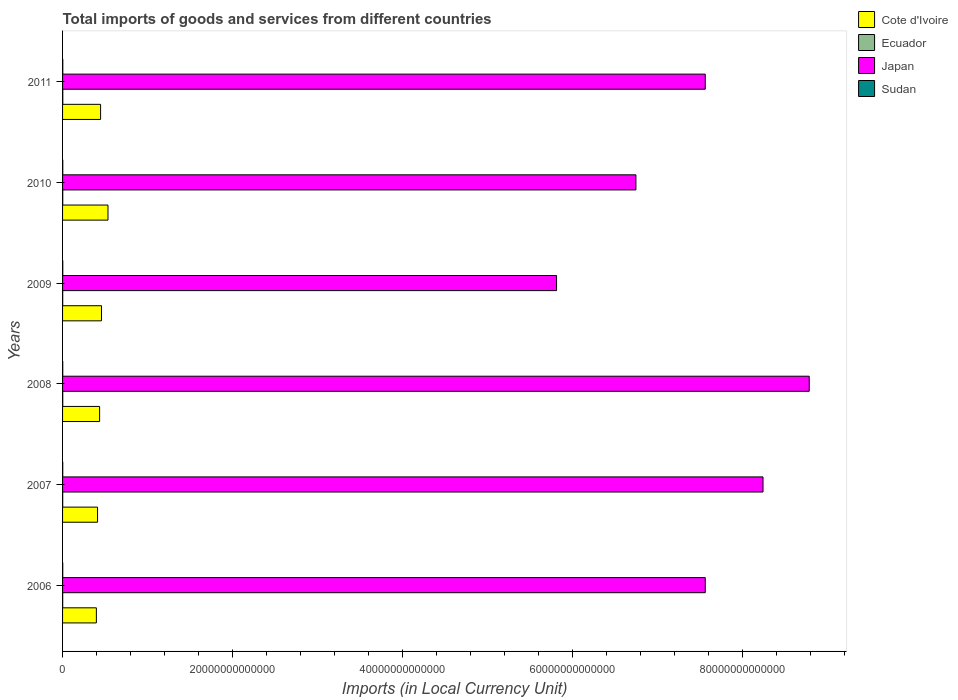How many different coloured bars are there?
Your answer should be compact. 4. How many groups of bars are there?
Your response must be concise. 6. Are the number of bars per tick equal to the number of legend labels?
Make the answer very short. Yes. Are the number of bars on each tick of the Y-axis equal?
Give a very brief answer. Yes. How many bars are there on the 1st tick from the bottom?
Provide a short and direct response. 4. What is the label of the 5th group of bars from the top?
Keep it short and to the point. 2007. In how many cases, is the number of bars for a given year not equal to the number of legend labels?
Keep it short and to the point. 0. What is the Amount of goods and services imports in Sudan in 2008?
Ensure brevity in your answer.  2.23e+1. Across all years, what is the maximum Amount of goods and services imports in Sudan?
Your response must be concise. 2.79e+1. Across all years, what is the minimum Amount of goods and services imports in Ecuador?
Your response must be concise. 1.37e+1. What is the total Amount of goods and services imports in Japan in the graph?
Offer a very short reply. 4.47e+14. What is the difference between the Amount of goods and services imports in Ecuador in 2008 and that in 2011?
Offer a very short reply. -5.52e+09. What is the difference between the Amount of goods and services imports in Ecuador in 2009 and the Amount of goods and services imports in Sudan in 2007?
Offer a terse response. -4.18e+09. What is the average Amount of goods and services imports in Ecuador per year?
Provide a succinct answer. 1.94e+1. In the year 2006, what is the difference between the Amount of goods and services imports in Ecuador and Amount of goods and services imports in Cote d'Ivoire?
Offer a terse response. -3.96e+12. What is the ratio of the Amount of goods and services imports in Sudan in 2007 to that in 2008?
Offer a very short reply. 0.94. Is the Amount of goods and services imports in Sudan in 2007 less than that in 2008?
Ensure brevity in your answer.  Yes. What is the difference between the highest and the second highest Amount of goods and services imports in Japan?
Provide a short and direct response. 5.43e+12. What is the difference between the highest and the lowest Amount of goods and services imports in Japan?
Make the answer very short. 2.97e+13. Is the sum of the Amount of goods and services imports in Sudan in 2006 and 2007 greater than the maximum Amount of goods and services imports in Japan across all years?
Keep it short and to the point. No. Is it the case that in every year, the sum of the Amount of goods and services imports in Sudan and Amount of goods and services imports in Japan is greater than the sum of Amount of goods and services imports in Cote d'Ivoire and Amount of goods and services imports in Ecuador?
Provide a short and direct response. Yes. What does the 2nd bar from the bottom in 2009 represents?
Give a very brief answer. Ecuador. Are all the bars in the graph horizontal?
Give a very brief answer. Yes. What is the difference between two consecutive major ticks on the X-axis?
Your response must be concise. 2.00e+13. Are the values on the major ticks of X-axis written in scientific E-notation?
Offer a terse response. No. Does the graph contain grids?
Ensure brevity in your answer.  No. Where does the legend appear in the graph?
Give a very brief answer. Top right. What is the title of the graph?
Your response must be concise. Total imports of goods and services from different countries. Does "Turkey" appear as one of the legend labels in the graph?
Give a very brief answer. No. What is the label or title of the X-axis?
Ensure brevity in your answer.  Imports (in Local Currency Unit). What is the label or title of the Y-axis?
Offer a terse response. Years. What is the Imports (in Local Currency Unit) of Cote d'Ivoire in 2006?
Offer a terse response. 3.97e+12. What is the Imports (in Local Currency Unit) of Ecuador in 2006?
Make the answer very short. 1.37e+1. What is the Imports (in Local Currency Unit) in Japan in 2006?
Your answer should be very brief. 7.56e+13. What is the Imports (in Local Currency Unit) of Sudan in 2006?
Ensure brevity in your answer.  2.07e+1. What is the Imports (in Local Currency Unit) of Cote d'Ivoire in 2007?
Offer a terse response. 4.12e+12. What is the Imports (in Local Currency Unit) of Ecuador in 2007?
Your response must be concise. 1.56e+1. What is the Imports (in Local Currency Unit) in Japan in 2007?
Ensure brevity in your answer.  8.24e+13. What is the Imports (in Local Currency Unit) in Sudan in 2007?
Your answer should be compact. 2.10e+1. What is the Imports (in Local Currency Unit) of Cote d'Ivoire in 2008?
Your answer should be very brief. 4.36e+12. What is the Imports (in Local Currency Unit) of Ecuador in 2008?
Keep it short and to the point. 2.09e+1. What is the Imports (in Local Currency Unit) of Japan in 2008?
Provide a succinct answer. 8.78e+13. What is the Imports (in Local Currency Unit) in Sudan in 2008?
Keep it short and to the point. 2.23e+1. What is the Imports (in Local Currency Unit) in Cote d'Ivoire in 2009?
Your answer should be compact. 4.58e+12. What is the Imports (in Local Currency Unit) in Ecuador in 2009?
Ensure brevity in your answer.  1.68e+1. What is the Imports (in Local Currency Unit) in Japan in 2009?
Make the answer very short. 5.81e+13. What is the Imports (in Local Currency Unit) in Sudan in 2009?
Offer a very short reply. 2.45e+1. What is the Imports (in Local Currency Unit) in Cote d'Ivoire in 2010?
Provide a succinct answer. 5.34e+12. What is the Imports (in Local Currency Unit) of Ecuador in 2010?
Your answer should be compact. 2.25e+1. What is the Imports (in Local Currency Unit) in Japan in 2010?
Your answer should be very brief. 6.74e+13. What is the Imports (in Local Currency Unit) in Sudan in 2010?
Offer a very short reply. 2.61e+1. What is the Imports (in Local Currency Unit) of Cote d'Ivoire in 2011?
Provide a short and direct response. 4.47e+12. What is the Imports (in Local Currency Unit) of Ecuador in 2011?
Your response must be concise. 2.65e+1. What is the Imports (in Local Currency Unit) in Japan in 2011?
Your response must be concise. 7.56e+13. What is the Imports (in Local Currency Unit) of Sudan in 2011?
Keep it short and to the point. 2.79e+1. Across all years, what is the maximum Imports (in Local Currency Unit) in Cote d'Ivoire?
Your response must be concise. 5.34e+12. Across all years, what is the maximum Imports (in Local Currency Unit) of Ecuador?
Ensure brevity in your answer.  2.65e+1. Across all years, what is the maximum Imports (in Local Currency Unit) of Japan?
Your answer should be very brief. 8.78e+13. Across all years, what is the maximum Imports (in Local Currency Unit) of Sudan?
Make the answer very short. 2.79e+1. Across all years, what is the minimum Imports (in Local Currency Unit) in Cote d'Ivoire?
Your answer should be very brief. 3.97e+12. Across all years, what is the minimum Imports (in Local Currency Unit) in Ecuador?
Offer a terse response. 1.37e+1. Across all years, what is the minimum Imports (in Local Currency Unit) in Japan?
Provide a short and direct response. 5.81e+13. Across all years, what is the minimum Imports (in Local Currency Unit) in Sudan?
Provide a short and direct response. 2.07e+1. What is the total Imports (in Local Currency Unit) of Cote d'Ivoire in the graph?
Provide a short and direct response. 2.68e+13. What is the total Imports (in Local Currency Unit) in Ecuador in the graph?
Your answer should be compact. 1.16e+11. What is the total Imports (in Local Currency Unit) in Japan in the graph?
Offer a very short reply. 4.47e+14. What is the total Imports (in Local Currency Unit) of Sudan in the graph?
Your answer should be very brief. 1.42e+11. What is the difference between the Imports (in Local Currency Unit) in Cote d'Ivoire in 2006 and that in 2007?
Your answer should be very brief. -1.41e+11. What is the difference between the Imports (in Local Currency Unit) of Ecuador in 2006 and that in 2007?
Your response must be concise. -1.89e+09. What is the difference between the Imports (in Local Currency Unit) of Japan in 2006 and that in 2007?
Ensure brevity in your answer.  -6.79e+12. What is the difference between the Imports (in Local Currency Unit) in Sudan in 2006 and that in 2007?
Give a very brief answer. -2.28e+08. What is the difference between the Imports (in Local Currency Unit) in Cote d'Ivoire in 2006 and that in 2008?
Provide a short and direct response. -3.82e+11. What is the difference between the Imports (in Local Currency Unit) of Ecuador in 2006 and that in 2008?
Ensure brevity in your answer.  -7.18e+09. What is the difference between the Imports (in Local Currency Unit) of Japan in 2006 and that in 2008?
Provide a succinct answer. -1.22e+13. What is the difference between the Imports (in Local Currency Unit) in Sudan in 2006 and that in 2008?
Offer a terse response. -1.58e+09. What is the difference between the Imports (in Local Currency Unit) of Cote d'Ivoire in 2006 and that in 2009?
Give a very brief answer. -6.02e+11. What is the difference between the Imports (in Local Currency Unit) of Ecuador in 2006 and that in 2009?
Your response must be concise. -3.04e+09. What is the difference between the Imports (in Local Currency Unit) of Japan in 2006 and that in 2009?
Provide a short and direct response. 1.75e+13. What is the difference between the Imports (in Local Currency Unit) in Sudan in 2006 and that in 2009?
Provide a succinct answer. -3.72e+09. What is the difference between the Imports (in Local Currency Unit) of Cote d'Ivoire in 2006 and that in 2010?
Offer a very short reply. -1.37e+12. What is the difference between the Imports (in Local Currency Unit) of Ecuador in 2006 and that in 2010?
Offer a very short reply. -8.79e+09. What is the difference between the Imports (in Local Currency Unit) in Japan in 2006 and that in 2010?
Your answer should be very brief. 8.15e+12. What is the difference between the Imports (in Local Currency Unit) of Sudan in 2006 and that in 2010?
Provide a succinct answer. -5.33e+09. What is the difference between the Imports (in Local Currency Unit) in Cote d'Ivoire in 2006 and that in 2011?
Your response must be concise. -4.97e+11. What is the difference between the Imports (in Local Currency Unit) of Ecuador in 2006 and that in 2011?
Your answer should be compact. -1.27e+1. What is the difference between the Imports (in Local Currency Unit) of Japan in 2006 and that in 2011?
Offer a terse response. -1.00e+08. What is the difference between the Imports (in Local Currency Unit) of Sudan in 2006 and that in 2011?
Keep it short and to the point. -7.16e+09. What is the difference between the Imports (in Local Currency Unit) in Cote d'Ivoire in 2007 and that in 2008?
Your response must be concise. -2.41e+11. What is the difference between the Imports (in Local Currency Unit) of Ecuador in 2007 and that in 2008?
Ensure brevity in your answer.  -5.30e+09. What is the difference between the Imports (in Local Currency Unit) of Japan in 2007 and that in 2008?
Your response must be concise. -5.43e+12. What is the difference between the Imports (in Local Currency Unit) in Sudan in 2007 and that in 2008?
Provide a short and direct response. -1.35e+09. What is the difference between the Imports (in Local Currency Unit) in Cote d'Ivoire in 2007 and that in 2009?
Provide a short and direct response. -4.61e+11. What is the difference between the Imports (in Local Currency Unit) of Ecuador in 2007 and that in 2009?
Offer a very short reply. -1.15e+09. What is the difference between the Imports (in Local Currency Unit) in Japan in 2007 and that in 2009?
Keep it short and to the point. 2.43e+13. What is the difference between the Imports (in Local Currency Unit) in Sudan in 2007 and that in 2009?
Give a very brief answer. -3.49e+09. What is the difference between the Imports (in Local Currency Unit) in Cote d'Ivoire in 2007 and that in 2010?
Provide a short and direct response. -1.22e+12. What is the difference between the Imports (in Local Currency Unit) of Ecuador in 2007 and that in 2010?
Your answer should be very brief. -6.91e+09. What is the difference between the Imports (in Local Currency Unit) of Japan in 2007 and that in 2010?
Your response must be concise. 1.49e+13. What is the difference between the Imports (in Local Currency Unit) in Sudan in 2007 and that in 2010?
Provide a succinct answer. -5.11e+09. What is the difference between the Imports (in Local Currency Unit) in Cote d'Ivoire in 2007 and that in 2011?
Your response must be concise. -3.56e+11. What is the difference between the Imports (in Local Currency Unit) in Ecuador in 2007 and that in 2011?
Offer a very short reply. -1.08e+1. What is the difference between the Imports (in Local Currency Unit) of Japan in 2007 and that in 2011?
Your answer should be very brief. 6.79e+12. What is the difference between the Imports (in Local Currency Unit) of Sudan in 2007 and that in 2011?
Give a very brief answer. -6.93e+09. What is the difference between the Imports (in Local Currency Unit) of Cote d'Ivoire in 2008 and that in 2009?
Offer a terse response. -2.20e+11. What is the difference between the Imports (in Local Currency Unit) in Ecuador in 2008 and that in 2009?
Give a very brief answer. 4.14e+09. What is the difference between the Imports (in Local Currency Unit) in Japan in 2008 and that in 2009?
Your answer should be very brief. 2.97e+13. What is the difference between the Imports (in Local Currency Unit) of Sudan in 2008 and that in 2009?
Keep it short and to the point. -2.14e+09. What is the difference between the Imports (in Local Currency Unit) in Cote d'Ivoire in 2008 and that in 2010?
Ensure brevity in your answer.  -9.83e+11. What is the difference between the Imports (in Local Currency Unit) in Ecuador in 2008 and that in 2010?
Your answer should be very brief. -1.61e+09. What is the difference between the Imports (in Local Currency Unit) in Japan in 2008 and that in 2010?
Keep it short and to the point. 2.04e+13. What is the difference between the Imports (in Local Currency Unit) of Sudan in 2008 and that in 2010?
Your answer should be compact. -3.75e+09. What is the difference between the Imports (in Local Currency Unit) of Cote d'Ivoire in 2008 and that in 2011?
Make the answer very short. -1.15e+11. What is the difference between the Imports (in Local Currency Unit) in Ecuador in 2008 and that in 2011?
Give a very brief answer. -5.52e+09. What is the difference between the Imports (in Local Currency Unit) of Japan in 2008 and that in 2011?
Make the answer very short. 1.22e+13. What is the difference between the Imports (in Local Currency Unit) in Sudan in 2008 and that in 2011?
Your answer should be very brief. -5.58e+09. What is the difference between the Imports (in Local Currency Unit) in Cote d'Ivoire in 2009 and that in 2010?
Offer a terse response. -7.63e+11. What is the difference between the Imports (in Local Currency Unit) in Ecuador in 2009 and that in 2010?
Your answer should be very brief. -5.75e+09. What is the difference between the Imports (in Local Currency Unit) in Japan in 2009 and that in 2010?
Your answer should be compact. -9.33e+12. What is the difference between the Imports (in Local Currency Unit) of Sudan in 2009 and that in 2010?
Your response must be concise. -1.62e+09. What is the difference between the Imports (in Local Currency Unit) of Cote d'Ivoire in 2009 and that in 2011?
Provide a succinct answer. 1.05e+11. What is the difference between the Imports (in Local Currency Unit) of Ecuador in 2009 and that in 2011?
Offer a terse response. -9.66e+09. What is the difference between the Imports (in Local Currency Unit) of Japan in 2009 and that in 2011?
Your answer should be compact. -1.75e+13. What is the difference between the Imports (in Local Currency Unit) of Sudan in 2009 and that in 2011?
Provide a short and direct response. -3.44e+09. What is the difference between the Imports (in Local Currency Unit) in Cote d'Ivoire in 2010 and that in 2011?
Your response must be concise. 8.68e+11. What is the difference between the Imports (in Local Currency Unit) of Ecuador in 2010 and that in 2011?
Keep it short and to the point. -3.91e+09. What is the difference between the Imports (in Local Currency Unit) of Japan in 2010 and that in 2011?
Provide a short and direct response. -8.15e+12. What is the difference between the Imports (in Local Currency Unit) in Sudan in 2010 and that in 2011?
Provide a succinct answer. -1.83e+09. What is the difference between the Imports (in Local Currency Unit) of Cote d'Ivoire in 2006 and the Imports (in Local Currency Unit) of Ecuador in 2007?
Your answer should be very brief. 3.96e+12. What is the difference between the Imports (in Local Currency Unit) of Cote d'Ivoire in 2006 and the Imports (in Local Currency Unit) of Japan in 2007?
Provide a succinct answer. -7.84e+13. What is the difference between the Imports (in Local Currency Unit) in Cote d'Ivoire in 2006 and the Imports (in Local Currency Unit) in Sudan in 2007?
Keep it short and to the point. 3.95e+12. What is the difference between the Imports (in Local Currency Unit) in Ecuador in 2006 and the Imports (in Local Currency Unit) in Japan in 2007?
Provide a succinct answer. -8.23e+13. What is the difference between the Imports (in Local Currency Unit) in Ecuador in 2006 and the Imports (in Local Currency Unit) in Sudan in 2007?
Ensure brevity in your answer.  -7.23e+09. What is the difference between the Imports (in Local Currency Unit) of Japan in 2006 and the Imports (in Local Currency Unit) of Sudan in 2007?
Provide a short and direct response. 7.56e+13. What is the difference between the Imports (in Local Currency Unit) of Cote d'Ivoire in 2006 and the Imports (in Local Currency Unit) of Ecuador in 2008?
Provide a succinct answer. 3.95e+12. What is the difference between the Imports (in Local Currency Unit) of Cote d'Ivoire in 2006 and the Imports (in Local Currency Unit) of Japan in 2008?
Your answer should be compact. -8.38e+13. What is the difference between the Imports (in Local Currency Unit) in Cote d'Ivoire in 2006 and the Imports (in Local Currency Unit) in Sudan in 2008?
Provide a succinct answer. 3.95e+12. What is the difference between the Imports (in Local Currency Unit) of Ecuador in 2006 and the Imports (in Local Currency Unit) of Japan in 2008?
Your answer should be compact. -8.78e+13. What is the difference between the Imports (in Local Currency Unit) of Ecuador in 2006 and the Imports (in Local Currency Unit) of Sudan in 2008?
Give a very brief answer. -8.58e+09. What is the difference between the Imports (in Local Currency Unit) in Japan in 2006 and the Imports (in Local Currency Unit) in Sudan in 2008?
Your answer should be compact. 7.55e+13. What is the difference between the Imports (in Local Currency Unit) of Cote d'Ivoire in 2006 and the Imports (in Local Currency Unit) of Ecuador in 2009?
Keep it short and to the point. 3.96e+12. What is the difference between the Imports (in Local Currency Unit) of Cote d'Ivoire in 2006 and the Imports (in Local Currency Unit) of Japan in 2009?
Make the answer very short. -5.41e+13. What is the difference between the Imports (in Local Currency Unit) of Cote d'Ivoire in 2006 and the Imports (in Local Currency Unit) of Sudan in 2009?
Offer a terse response. 3.95e+12. What is the difference between the Imports (in Local Currency Unit) in Ecuador in 2006 and the Imports (in Local Currency Unit) in Japan in 2009?
Provide a succinct answer. -5.81e+13. What is the difference between the Imports (in Local Currency Unit) in Ecuador in 2006 and the Imports (in Local Currency Unit) in Sudan in 2009?
Give a very brief answer. -1.07e+1. What is the difference between the Imports (in Local Currency Unit) of Japan in 2006 and the Imports (in Local Currency Unit) of Sudan in 2009?
Keep it short and to the point. 7.55e+13. What is the difference between the Imports (in Local Currency Unit) in Cote d'Ivoire in 2006 and the Imports (in Local Currency Unit) in Ecuador in 2010?
Provide a succinct answer. 3.95e+12. What is the difference between the Imports (in Local Currency Unit) in Cote d'Ivoire in 2006 and the Imports (in Local Currency Unit) in Japan in 2010?
Provide a succinct answer. -6.34e+13. What is the difference between the Imports (in Local Currency Unit) in Cote d'Ivoire in 2006 and the Imports (in Local Currency Unit) in Sudan in 2010?
Offer a terse response. 3.95e+12. What is the difference between the Imports (in Local Currency Unit) in Ecuador in 2006 and the Imports (in Local Currency Unit) in Japan in 2010?
Keep it short and to the point. -6.74e+13. What is the difference between the Imports (in Local Currency Unit) of Ecuador in 2006 and the Imports (in Local Currency Unit) of Sudan in 2010?
Offer a very short reply. -1.23e+1. What is the difference between the Imports (in Local Currency Unit) of Japan in 2006 and the Imports (in Local Currency Unit) of Sudan in 2010?
Your answer should be compact. 7.55e+13. What is the difference between the Imports (in Local Currency Unit) of Cote d'Ivoire in 2006 and the Imports (in Local Currency Unit) of Ecuador in 2011?
Your response must be concise. 3.95e+12. What is the difference between the Imports (in Local Currency Unit) of Cote d'Ivoire in 2006 and the Imports (in Local Currency Unit) of Japan in 2011?
Give a very brief answer. -7.16e+13. What is the difference between the Imports (in Local Currency Unit) in Cote d'Ivoire in 2006 and the Imports (in Local Currency Unit) in Sudan in 2011?
Make the answer very short. 3.95e+12. What is the difference between the Imports (in Local Currency Unit) of Ecuador in 2006 and the Imports (in Local Currency Unit) of Japan in 2011?
Offer a very short reply. -7.56e+13. What is the difference between the Imports (in Local Currency Unit) in Ecuador in 2006 and the Imports (in Local Currency Unit) in Sudan in 2011?
Your response must be concise. -1.42e+1. What is the difference between the Imports (in Local Currency Unit) in Japan in 2006 and the Imports (in Local Currency Unit) in Sudan in 2011?
Make the answer very short. 7.55e+13. What is the difference between the Imports (in Local Currency Unit) in Cote d'Ivoire in 2007 and the Imports (in Local Currency Unit) in Ecuador in 2008?
Offer a terse response. 4.09e+12. What is the difference between the Imports (in Local Currency Unit) of Cote d'Ivoire in 2007 and the Imports (in Local Currency Unit) of Japan in 2008?
Ensure brevity in your answer.  -8.37e+13. What is the difference between the Imports (in Local Currency Unit) of Cote d'Ivoire in 2007 and the Imports (in Local Currency Unit) of Sudan in 2008?
Give a very brief answer. 4.09e+12. What is the difference between the Imports (in Local Currency Unit) in Ecuador in 2007 and the Imports (in Local Currency Unit) in Japan in 2008?
Your answer should be compact. -8.78e+13. What is the difference between the Imports (in Local Currency Unit) of Ecuador in 2007 and the Imports (in Local Currency Unit) of Sudan in 2008?
Provide a short and direct response. -6.69e+09. What is the difference between the Imports (in Local Currency Unit) of Japan in 2007 and the Imports (in Local Currency Unit) of Sudan in 2008?
Ensure brevity in your answer.  8.23e+13. What is the difference between the Imports (in Local Currency Unit) of Cote d'Ivoire in 2007 and the Imports (in Local Currency Unit) of Ecuador in 2009?
Your answer should be compact. 4.10e+12. What is the difference between the Imports (in Local Currency Unit) in Cote d'Ivoire in 2007 and the Imports (in Local Currency Unit) in Japan in 2009?
Make the answer very short. -5.40e+13. What is the difference between the Imports (in Local Currency Unit) in Cote d'Ivoire in 2007 and the Imports (in Local Currency Unit) in Sudan in 2009?
Keep it short and to the point. 4.09e+12. What is the difference between the Imports (in Local Currency Unit) in Ecuador in 2007 and the Imports (in Local Currency Unit) in Japan in 2009?
Offer a very short reply. -5.81e+13. What is the difference between the Imports (in Local Currency Unit) in Ecuador in 2007 and the Imports (in Local Currency Unit) in Sudan in 2009?
Ensure brevity in your answer.  -8.83e+09. What is the difference between the Imports (in Local Currency Unit) of Japan in 2007 and the Imports (in Local Currency Unit) of Sudan in 2009?
Ensure brevity in your answer.  8.23e+13. What is the difference between the Imports (in Local Currency Unit) in Cote d'Ivoire in 2007 and the Imports (in Local Currency Unit) in Ecuador in 2010?
Make the answer very short. 4.09e+12. What is the difference between the Imports (in Local Currency Unit) of Cote d'Ivoire in 2007 and the Imports (in Local Currency Unit) of Japan in 2010?
Keep it short and to the point. -6.33e+13. What is the difference between the Imports (in Local Currency Unit) of Cote d'Ivoire in 2007 and the Imports (in Local Currency Unit) of Sudan in 2010?
Your answer should be very brief. 4.09e+12. What is the difference between the Imports (in Local Currency Unit) of Ecuador in 2007 and the Imports (in Local Currency Unit) of Japan in 2010?
Keep it short and to the point. -6.74e+13. What is the difference between the Imports (in Local Currency Unit) of Ecuador in 2007 and the Imports (in Local Currency Unit) of Sudan in 2010?
Your response must be concise. -1.04e+1. What is the difference between the Imports (in Local Currency Unit) in Japan in 2007 and the Imports (in Local Currency Unit) in Sudan in 2010?
Your response must be concise. 8.23e+13. What is the difference between the Imports (in Local Currency Unit) of Cote d'Ivoire in 2007 and the Imports (in Local Currency Unit) of Ecuador in 2011?
Make the answer very short. 4.09e+12. What is the difference between the Imports (in Local Currency Unit) in Cote d'Ivoire in 2007 and the Imports (in Local Currency Unit) in Japan in 2011?
Offer a very short reply. -7.15e+13. What is the difference between the Imports (in Local Currency Unit) of Cote d'Ivoire in 2007 and the Imports (in Local Currency Unit) of Sudan in 2011?
Give a very brief answer. 4.09e+12. What is the difference between the Imports (in Local Currency Unit) of Ecuador in 2007 and the Imports (in Local Currency Unit) of Japan in 2011?
Ensure brevity in your answer.  -7.56e+13. What is the difference between the Imports (in Local Currency Unit) of Ecuador in 2007 and the Imports (in Local Currency Unit) of Sudan in 2011?
Ensure brevity in your answer.  -1.23e+1. What is the difference between the Imports (in Local Currency Unit) of Japan in 2007 and the Imports (in Local Currency Unit) of Sudan in 2011?
Offer a very short reply. 8.23e+13. What is the difference between the Imports (in Local Currency Unit) in Cote d'Ivoire in 2008 and the Imports (in Local Currency Unit) in Ecuador in 2009?
Make the answer very short. 4.34e+12. What is the difference between the Imports (in Local Currency Unit) of Cote d'Ivoire in 2008 and the Imports (in Local Currency Unit) of Japan in 2009?
Offer a very short reply. -5.37e+13. What is the difference between the Imports (in Local Currency Unit) of Cote d'Ivoire in 2008 and the Imports (in Local Currency Unit) of Sudan in 2009?
Offer a terse response. 4.33e+12. What is the difference between the Imports (in Local Currency Unit) of Ecuador in 2008 and the Imports (in Local Currency Unit) of Japan in 2009?
Ensure brevity in your answer.  -5.81e+13. What is the difference between the Imports (in Local Currency Unit) in Ecuador in 2008 and the Imports (in Local Currency Unit) in Sudan in 2009?
Give a very brief answer. -3.53e+09. What is the difference between the Imports (in Local Currency Unit) of Japan in 2008 and the Imports (in Local Currency Unit) of Sudan in 2009?
Offer a terse response. 8.78e+13. What is the difference between the Imports (in Local Currency Unit) of Cote d'Ivoire in 2008 and the Imports (in Local Currency Unit) of Ecuador in 2010?
Give a very brief answer. 4.33e+12. What is the difference between the Imports (in Local Currency Unit) in Cote d'Ivoire in 2008 and the Imports (in Local Currency Unit) in Japan in 2010?
Offer a very short reply. -6.31e+13. What is the difference between the Imports (in Local Currency Unit) of Cote d'Ivoire in 2008 and the Imports (in Local Currency Unit) of Sudan in 2010?
Offer a terse response. 4.33e+12. What is the difference between the Imports (in Local Currency Unit) of Ecuador in 2008 and the Imports (in Local Currency Unit) of Japan in 2010?
Make the answer very short. -6.74e+13. What is the difference between the Imports (in Local Currency Unit) in Ecuador in 2008 and the Imports (in Local Currency Unit) in Sudan in 2010?
Make the answer very short. -5.15e+09. What is the difference between the Imports (in Local Currency Unit) in Japan in 2008 and the Imports (in Local Currency Unit) in Sudan in 2010?
Your response must be concise. 8.78e+13. What is the difference between the Imports (in Local Currency Unit) of Cote d'Ivoire in 2008 and the Imports (in Local Currency Unit) of Ecuador in 2011?
Offer a very short reply. 4.33e+12. What is the difference between the Imports (in Local Currency Unit) of Cote d'Ivoire in 2008 and the Imports (in Local Currency Unit) of Japan in 2011?
Provide a succinct answer. -7.12e+13. What is the difference between the Imports (in Local Currency Unit) of Cote d'Ivoire in 2008 and the Imports (in Local Currency Unit) of Sudan in 2011?
Provide a succinct answer. 4.33e+12. What is the difference between the Imports (in Local Currency Unit) of Ecuador in 2008 and the Imports (in Local Currency Unit) of Japan in 2011?
Your answer should be compact. -7.56e+13. What is the difference between the Imports (in Local Currency Unit) of Ecuador in 2008 and the Imports (in Local Currency Unit) of Sudan in 2011?
Give a very brief answer. -6.97e+09. What is the difference between the Imports (in Local Currency Unit) of Japan in 2008 and the Imports (in Local Currency Unit) of Sudan in 2011?
Your answer should be very brief. 8.78e+13. What is the difference between the Imports (in Local Currency Unit) in Cote d'Ivoire in 2009 and the Imports (in Local Currency Unit) in Ecuador in 2010?
Your response must be concise. 4.55e+12. What is the difference between the Imports (in Local Currency Unit) in Cote d'Ivoire in 2009 and the Imports (in Local Currency Unit) in Japan in 2010?
Provide a succinct answer. -6.28e+13. What is the difference between the Imports (in Local Currency Unit) of Cote d'Ivoire in 2009 and the Imports (in Local Currency Unit) of Sudan in 2010?
Your response must be concise. 4.55e+12. What is the difference between the Imports (in Local Currency Unit) in Ecuador in 2009 and the Imports (in Local Currency Unit) in Japan in 2010?
Offer a very short reply. -6.74e+13. What is the difference between the Imports (in Local Currency Unit) in Ecuador in 2009 and the Imports (in Local Currency Unit) in Sudan in 2010?
Provide a succinct answer. -9.29e+09. What is the difference between the Imports (in Local Currency Unit) in Japan in 2009 and the Imports (in Local Currency Unit) in Sudan in 2010?
Keep it short and to the point. 5.81e+13. What is the difference between the Imports (in Local Currency Unit) in Cote d'Ivoire in 2009 and the Imports (in Local Currency Unit) in Ecuador in 2011?
Ensure brevity in your answer.  4.55e+12. What is the difference between the Imports (in Local Currency Unit) of Cote d'Ivoire in 2009 and the Imports (in Local Currency Unit) of Japan in 2011?
Keep it short and to the point. -7.10e+13. What is the difference between the Imports (in Local Currency Unit) of Cote d'Ivoire in 2009 and the Imports (in Local Currency Unit) of Sudan in 2011?
Offer a terse response. 4.55e+12. What is the difference between the Imports (in Local Currency Unit) in Ecuador in 2009 and the Imports (in Local Currency Unit) in Japan in 2011?
Your answer should be very brief. -7.56e+13. What is the difference between the Imports (in Local Currency Unit) in Ecuador in 2009 and the Imports (in Local Currency Unit) in Sudan in 2011?
Your response must be concise. -1.11e+1. What is the difference between the Imports (in Local Currency Unit) of Japan in 2009 and the Imports (in Local Currency Unit) of Sudan in 2011?
Offer a very short reply. 5.81e+13. What is the difference between the Imports (in Local Currency Unit) in Cote d'Ivoire in 2010 and the Imports (in Local Currency Unit) in Ecuador in 2011?
Make the answer very short. 5.31e+12. What is the difference between the Imports (in Local Currency Unit) in Cote d'Ivoire in 2010 and the Imports (in Local Currency Unit) in Japan in 2011?
Your response must be concise. -7.02e+13. What is the difference between the Imports (in Local Currency Unit) of Cote d'Ivoire in 2010 and the Imports (in Local Currency Unit) of Sudan in 2011?
Your answer should be very brief. 5.31e+12. What is the difference between the Imports (in Local Currency Unit) of Ecuador in 2010 and the Imports (in Local Currency Unit) of Japan in 2011?
Provide a succinct answer. -7.55e+13. What is the difference between the Imports (in Local Currency Unit) in Ecuador in 2010 and the Imports (in Local Currency Unit) in Sudan in 2011?
Offer a terse response. -5.37e+09. What is the difference between the Imports (in Local Currency Unit) of Japan in 2010 and the Imports (in Local Currency Unit) of Sudan in 2011?
Your response must be concise. 6.74e+13. What is the average Imports (in Local Currency Unit) of Cote d'Ivoire per year?
Your answer should be compact. 4.47e+12. What is the average Imports (in Local Currency Unit) of Ecuador per year?
Provide a succinct answer. 1.94e+1. What is the average Imports (in Local Currency Unit) of Japan per year?
Offer a terse response. 7.45e+13. What is the average Imports (in Local Currency Unit) in Sudan per year?
Offer a very short reply. 2.37e+1. In the year 2006, what is the difference between the Imports (in Local Currency Unit) of Cote d'Ivoire and Imports (in Local Currency Unit) of Ecuador?
Give a very brief answer. 3.96e+12. In the year 2006, what is the difference between the Imports (in Local Currency Unit) of Cote d'Ivoire and Imports (in Local Currency Unit) of Japan?
Keep it short and to the point. -7.16e+13. In the year 2006, what is the difference between the Imports (in Local Currency Unit) in Cote d'Ivoire and Imports (in Local Currency Unit) in Sudan?
Give a very brief answer. 3.95e+12. In the year 2006, what is the difference between the Imports (in Local Currency Unit) in Ecuador and Imports (in Local Currency Unit) in Japan?
Your answer should be very brief. -7.56e+13. In the year 2006, what is the difference between the Imports (in Local Currency Unit) of Ecuador and Imports (in Local Currency Unit) of Sudan?
Your response must be concise. -7.00e+09. In the year 2006, what is the difference between the Imports (in Local Currency Unit) of Japan and Imports (in Local Currency Unit) of Sudan?
Provide a short and direct response. 7.56e+13. In the year 2007, what is the difference between the Imports (in Local Currency Unit) in Cote d'Ivoire and Imports (in Local Currency Unit) in Ecuador?
Offer a very short reply. 4.10e+12. In the year 2007, what is the difference between the Imports (in Local Currency Unit) of Cote d'Ivoire and Imports (in Local Currency Unit) of Japan?
Provide a succinct answer. -7.82e+13. In the year 2007, what is the difference between the Imports (in Local Currency Unit) of Cote d'Ivoire and Imports (in Local Currency Unit) of Sudan?
Your answer should be very brief. 4.09e+12. In the year 2007, what is the difference between the Imports (in Local Currency Unit) in Ecuador and Imports (in Local Currency Unit) in Japan?
Offer a terse response. -8.23e+13. In the year 2007, what is the difference between the Imports (in Local Currency Unit) of Ecuador and Imports (in Local Currency Unit) of Sudan?
Give a very brief answer. -5.34e+09. In the year 2007, what is the difference between the Imports (in Local Currency Unit) of Japan and Imports (in Local Currency Unit) of Sudan?
Your answer should be very brief. 8.23e+13. In the year 2008, what is the difference between the Imports (in Local Currency Unit) in Cote d'Ivoire and Imports (in Local Currency Unit) in Ecuador?
Make the answer very short. 4.34e+12. In the year 2008, what is the difference between the Imports (in Local Currency Unit) of Cote d'Ivoire and Imports (in Local Currency Unit) of Japan?
Give a very brief answer. -8.34e+13. In the year 2008, what is the difference between the Imports (in Local Currency Unit) of Cote d'Ivoire and Imports (in Local Currency Unit) of Sudan?
Provide a short and direct response. 4.33e+12. In the year 2008, what is the difference between the Imports (in Local Currency Unit) in Ecuador and Imports (in Local Currency Unit) in Japan?
Ensure brevity in your answer.  -8.78e+13. In the year 2008, what is the difference between the Imports (in Local Currency Unit) of Ecuador and Imports (in Local Currency Unit) of Sudan?
Make the answer very short. -1.39e+09. In the year 2008, what is the difference between the Imports (in Local Currency Unit) in Japan and Imports (in Local Currency Unit) in Sudan?
Provide a succinct answer. 8.78e+13. In the year 2009, what is the difference between the Imports (in Local Currency Unit) of Cote d'Ivoire and Imports (in Local Currency Unit) of Ecuador?
Your response must be concise. 4.56e+12. In the year 2009, what is the difference between the Imports (in Local Currency Unit) of Cote d'Ivoire and Imports (in Local Currency Unit) of Japan?
Ensure brevity in your answer.  -5.35e+13. In the year 2009, what is the difference between the Imports (in Local Currency Unit) in Cote d'Ivoire and Imports (in Local Currency Unit) in Sudan?
Offer a terse response. 4.55e+12. In the year 2009, what is the difference between the Imports (in Local Currency Unit) of Ecuador and Imports (in Local Currency Unit) of Japan?
Offer a terse response. -5.81e+13. In the year 2009, what is the difference between the Imports (in Local Currency Unit) of Ecuador and Imports (in Local Currency Unit) of Sudan?
Your response must be concise. -7.67e+09. In the year 2009, what is the difference between the Imports (in Local Currency Unit) in Japan and Imports (in Local Currency Unit) in Sudan?
Ensure brevity in your answer.  5.81e+13. In the year 2010, what is the difference between the Imports (in Local Currency Unit) of Cote d'Ivoire and Imports (in Local Currency Unit) of Ecuador?
Offer a terse response. 5.32e+12. In the year 2010, what is the difference between the Imports (in Local Currency Unit) of Cote d'Ivoire and Imports (in Local Currency Unit) of Japan?
Keep it short and to the point. -6.21e+13. In the year 2010, what is the difference between the Imports (in Local Currency Unit) in Cote d'Ivoire and Imports (in Local Currency Unit) in Sudan?
Offer a terse response. 5.31e+12. In the year 2010, what is the difference between the Imports (in Local Currency Unit) of Ecuador and Imports (in Local Currency Unit) of Japan?
Ensure brevity in your answer.  -6.74e+13. In the year 2010, what is the difference between the Imports (in Local Currency Unit) in Ecuador and Imports (in Local Currency Unit) in Sudan?
Ensure brevity in your answer.  -3.54e+09. In the year 2010, what is the difference between the Imports (in Local Currency Unit) of Japan and Imports (in Local Currency Unit) of Sudan?
Give a very brief answer. 6.74e+13. In the year 2011, what is the difference between the Imports (in Local Currency Unit) of Cote d'Ivoire and Imports (in Local Currency Unit) of Ecuador?
Offer a terse response. 4.45e+12. In the year 2011, what is the difference between the Imports (in Local Currency Unit) of Cote d'Ivoire and Imports (in Local Currency Unit) of Japan?
Offer a terse response. -7.11e+13. In the year 2011, what is the difference between the Imports (in Local Currency Unit) in Cote d'Ivoire and Imports (in Local Currency Unit) in Sudan?
Make the answer very short. 4.44e+12. In the year 2011, what is the difference between the Imports (in Local Currency Unit) of Ecuador and Imports (in Local Currency Unit) of Japan?
Your answer should be compact. -7.55e+13. In the year 2011, what is the difference between the Imports (in Local Currency Unit) in Ecuador and Imports (in Local Currency Unit) in Sudan?
Your response must be concise. -1.45e+09. In the year 2011, what is the difference between the Imports (in Local Currency Unit) of Japan and Imports (in Local Currency Unit) of Sudan?
Your answer should be compact. 7.55e+13. What is the ratio of the Imports (in Local Currency Unit) of Cote d'Ivoire in 2006 to that in 2007?
Provide a succinct answer. 0.97. What is the ratio of the Imports (in Local Currency Unit) in Ecuador in 2006 to that in 2007?
Your response must be concise. 0.88. What is the ratio of the Imports (in Local Currency Unit) in Japan in 2006 to that in 2007?
Your answer should be compact. 0.92. What is the ratio of the Imports (in Local Currency Unit) in Sudan in 2006 to that in 2007?
Give a very brief answer. 0.99. What is the ratio of the Imports (in Local Currency Unit) in Cote d'Ivoire in 2006 to that in 2008?
Ensure brevity in your answer.  0.91. What is the ratio of the Imports (in Local Currency Unit) of Ecuador in 2006 to that in 2008?
Provide a succinct answer. 0.66. What is the ratio of the Imports (in Local Currency Unit) of Japan in 2006 to that in 2008?
Your response must be concise. 0.86. What is the ratio of the Imports (in Local Currency Unit) in Sudan in 2006 to that in 2008?
Make the answer very short. 0.93. What is the ratio of the Imports (in Local Currency Unit) of Cote d'Ivoire in 2006 to that in 2009?
Offer a terse response. 0.87. What is the ratio of the Imports (in Local Currency Unit) in Ecuador in 2006 to that in 2009?
Your response must be concise. 0.82. What is the ratio of the Imports (in Local Currency Unit) in Japan in 2006 to that in 2009?
Ensure brevity in your answer.  1.3. What is the ratio of the Imports (in Local Currency Unit) of Sudan in 2006 to that in 2009?
Keep it short and to the point. 0.85. What is the ratio of the Imports (in Local Currency Unit) of Cote d'Ivoire in 2006 to that in 2010?
Provide a short and direct response. 0.74. What is the ratio of the Imports (in Local Currency Unit) in Ecuador in 2006 to that in 2010?
Your response must be concise. 0.61. What is the ratio of the Imports (in Local Currency Unit) of Japan in 2006 to that in 2010?
Offer a very short reply. 1.12. What is the ratio of the Imports (in Local Currency Unit) of Sudan in 2006 to that in 2010?
Your answer should be very brief. 0.8. What is the ratio of the Imports (in Local Currency Unit) of Ecuador in 2006 to that in 2011?
Give a very brief answer. 0.52. What is the ratio of the Imports (in Local Currency Unit) in Japan in 2006 to that in 2011?
Offer a terse response. 1. What is the ratio of the Imports (in Local Currency Unit) of Sudan in 2006 to that in 2011?
Keep it short and to the point. 0.74. What is the ratio of the Imports (in Local Currency Unit) in Cote d'Ivoire in 2007 to that in 2008?
Ensure brevity in your answer.  0.94. What is the ratio of the Imports (in Local Currency Unit) in Ecuador in 2007 to that in 2008?
Provide a succinct answer. 0.75. What is the ratio of the Imports (in Local Currency Unit) in Japan in 2007 to that in 2008?
Offer a very short reply. 0.94. What is the ratio of the Imports (in Local Currency Unit) in Sudan in 2007 to that in 2008?
Provide a short and direct response. 0.94. What is the ratio of the Imports (in Local Currency Unit) in Cote d'Ivoire in 2007 to that in 2009?
Your response must be concise. 0.9. What is the ratio of the Imports (in Local Currency Unit) of Ecuador in 2007 to that in 2009?
Offer a very short reply. 0.93. What is the ratio of the Imports (in Local Currency Unit) in Japan in 2007 to that in 2009?
Your answer should be very brief. 1.42. What is the ratio of the Imports (in Local Currency Unit) of Sudan in 2007 to that in 2009?
Provide a succinct answer. 0.86. What is the ratio of the Imports (in Local Currency Unit) of Cote d'Ivoire in 2007 to that in 2010?
Your answer should be compact. 0.77. What is the ratio of the Imports (in Local Currency Unit) in Ecuador in 2007 to that in 2010?
Your response must be concise. 0.69. What is the ratio of the Imports (in Local Currency Unit) of Japan in 2007 to that in 2010?
Offer a very short reply. 1.22. What is the ratio of the Imports (in Local Currency Unit) of Sudan in 2007 to that in 2010?
Provide a succinct answer. 0.8. What is the ratio of the Imports (in Local Currency Unit) in Cote d'Ivoire in 2007 to that in 2011?
Provide a short and direct response. 0.92. What is the ratio of the Imports (in Local Currency Unit) in Ecuador in 2007 to that in 2011?
Offer a very short reply. 0.59. What is the ratio of the Imports (in Local Currency Unit) in Japan in 2007 to that in 2011?
Provide a short and direct response. 1.09. What is the ratio of the Imports (in Local Currency Unit) of Sudan in 2007 to that in 2011?
Give a very brief answer. 0.75. What is the ratio of the Imports (in Local Currency Unit) in Cote d'Ivoire in 2008 to that in 2009?
Offer a very short reply. 0.95. What is the ratio of the Imports (in Local Currency Unit) in Ecuador in 2008 to that in 2009?
Keep it short and to the point. 1.25. What is the ratio of the Imports (in Local Currency Unit) of Japan in 2008 to that in 2009?
Offer a terse response. 1.51. What is the ratio of the Imports (in Local Currency Unit) of Sudan in 2008 to that in 2009?
Ensure brevity in your answer.  0.91. What is the ratio of the Imports (in Local Currency Unit) of Cote d'Ivoire in 2008 to that in 2010?
Give a very brief answer. 0.82. What is the ratio of the Imports (in Local Currency Unit) of Ecuador in 2008 to that in 2010?
Provide a short and direct response. 0.93. What is the ratio of the Imports (in Local Currency Unit) of Japan in 2008 to that in 2010?
Offer a terse response. 1.3. What is the ratio of the Imports (in Local Currency Unit) in Sudan in 2008 to that in 2010?
Give a very brief answer. 0.86. What is the ratio of the Imports (in Local Currency Unit) of Cote d'Ivoire in 2008 to that in 2011?
Offer a very short reply. 0.97. What is the ratio of the Imports (in Local Currency Unit) in Ecuador in 2008 to that in 2011?
Make the answer very short. 0.79. What is the ratio of the Imports (in Local Currency Unit) of Japan in 2008 to that in 2011?
Offer a very short reply. 1.16. What is the ratio of the Imports (in Local Currency Unit) in Cote d'Ivoire in 2009 to that in 2010?
Make the answer very short. 0.86. What is the ratio of the Imports (in Local Currency Unit) of Ecuador in 2009 to that in 2010?
Offer a terse response. 0.74. What is the ratio of the Imports (in Local Currency Unit) in Japan in 2009 to that in 2010?
Your answer should be very brief. 0.86. What is the ratio of the Imports (in Local Currency Unit) in Sudan in 2009 to that in 2010?
Provide a succinct answer. 0.94. What is the ratio of the Imports (in Local Currency Unit) in Cote d'Ivoire in 2009 to that in 2011?
Your response must be concise. 1.02. What is the ratio of the Imports (in Local Currency Unit) of Ecuador in 2009 to that in 2011?
Offer a very short reply. 0.63. What is the ratio of the Imports (in Local Currency Unit) in Japan in 2009 to that in 2011?
Provide a short and direct response. 0.77. What is the ratio of the Imports (in Local Currency Unit) of Sudan in 2009 to that in 2011?
Provide a short and direct response. 0.88. What is the ratio of the Imports (in Local Currency Unit) of Cote d'Ivoire in 2010 to that in 2011?
Make the answer very short. 1.19. What is the ratio of the Imports (in Local Currency Unit) of Ecuador in 2010 to that in 2011?
Your answer should be compact. 0.85. What is the ratio of the Imports (in Local Currency Unit) in Japan in 2010 to that in 2011?
Offer a terse response. 0.89. What is the ratio of the Imports (in Local Currency Unit) in Sudan in 2010 to that in 2011?
Your answer should be compact. 0.93. What is the difference between the highest and the second highest Imports (in Local Currency Unit) of Cote d'Ivoire?
Give a very brief answer. 7.63e+11. What is the difference between the highest and the second highest Imports (in Local Currency Unit) of Ecuador?
Give a very brief answer. 3.91e+09. What is the difference between the highest and the second highest Imports (in Local Currency Unit) of Japan?
Your answer should be very brief. 5.43e+12. What is the difference between the highest and the second highest Imports (in Local Currency Unit) of Sudan?
Provide a succinct answer. 1.83e+09. What is the difference between the highest and the lowest Imports (in Local Currency Unit) in Cote d'Ivoire?
Ensure brevity in your answer.  1.37e+12. What is the difference between the highest and the lowest Imports (in Local Currency Unit) in Ecuador?
Offer a terse response. 1.27e+1. What is the difference between the highest and the lowest Imports (in Local Currency Unit) in Japan?
Provide a succinct answer. 2.97e+13. What is the difference between the highest and the lowest Imports (in Local Currency Unit) in Sudan?
Your response must be concise. 7.16e+09. 